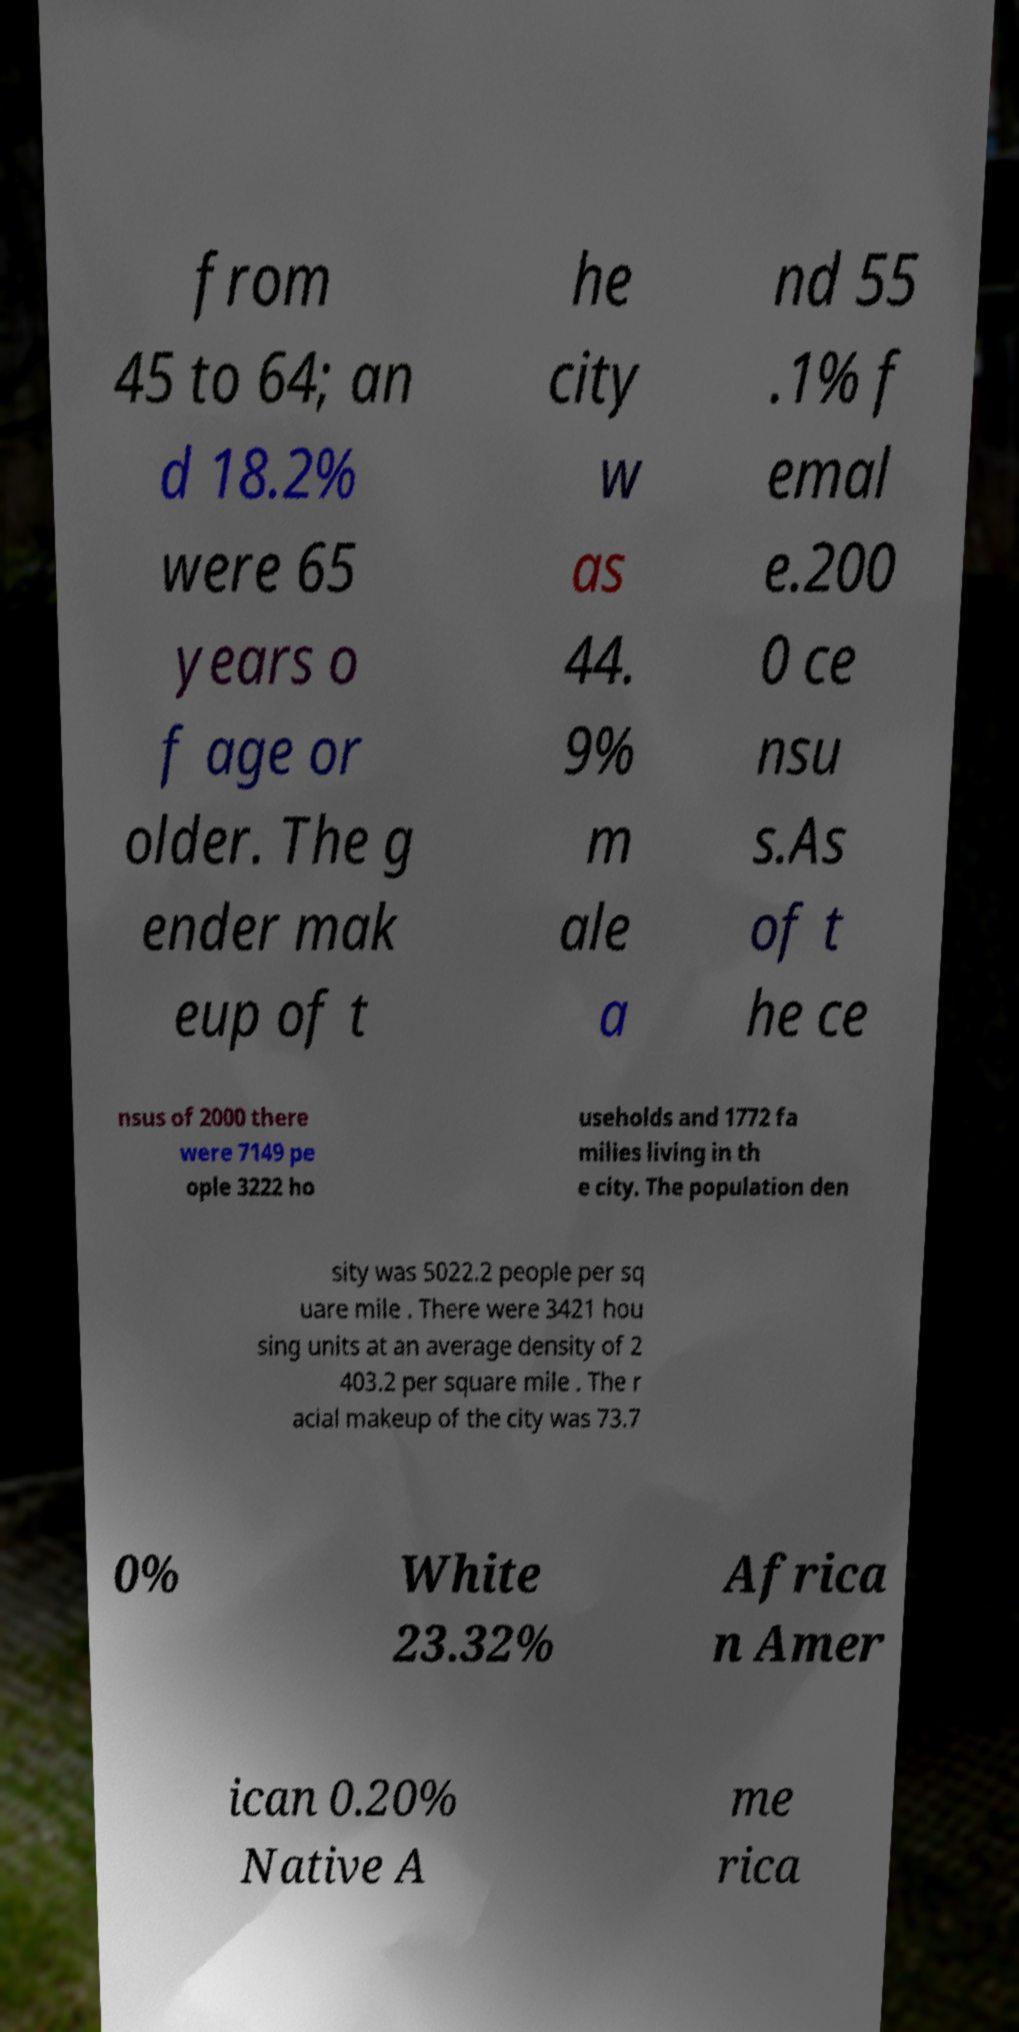Please identify and transcribe the text found in this image. from 45 to 64; an d 18.2% were 65 years o f age or older. The g ender mak eup of t he city w as 44. 9% m ale a nd 55 .1% f emal e.200 0 ce nsu s.As of t he ce nsus of 2000 there were 7149 pe ople 3222 ho useholds and 1772 fa milies living in th e city. The population den sity was 5022.2 people per sq uare mile . There were 3421 hou sing units at an average density of 2 403.2 per square mile . The r acial makeup of the city was 73.7 0% White 23.32% Africa n Amer ican 0.20% Native A me rica 